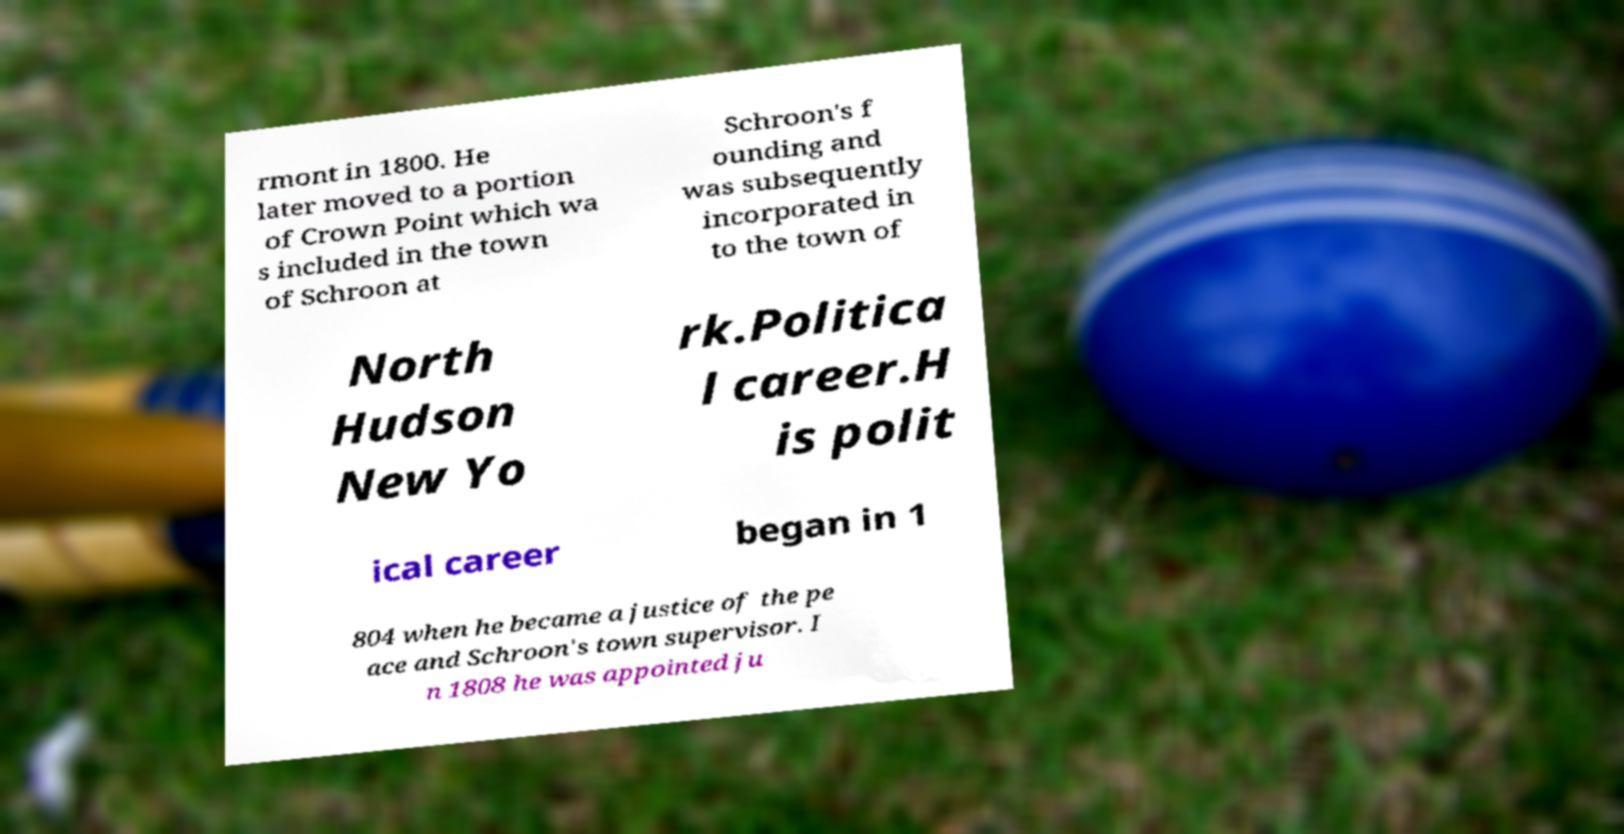Could you assist in decoding the text presented in this image and type it out clearly? rmont in 1800. He later moved to a portion of Crown Point which wa s included in the town of Schroon at Schroon's f ounding and was subsequently incorporated in to the town of North Hudson New Yo rk.Politica l career.H is polit ical career began in 1 804 when he became a justice of the pe ace and Schroon's town supervisor. I n 1808 he was appointed ju 